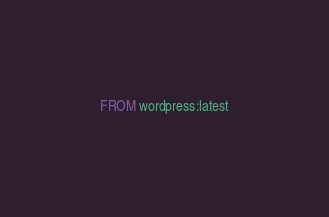<code> <loc_0><loc_0><loc_500><loc_500><_Dockerfile_>FROM wordpress:latest
</code> 